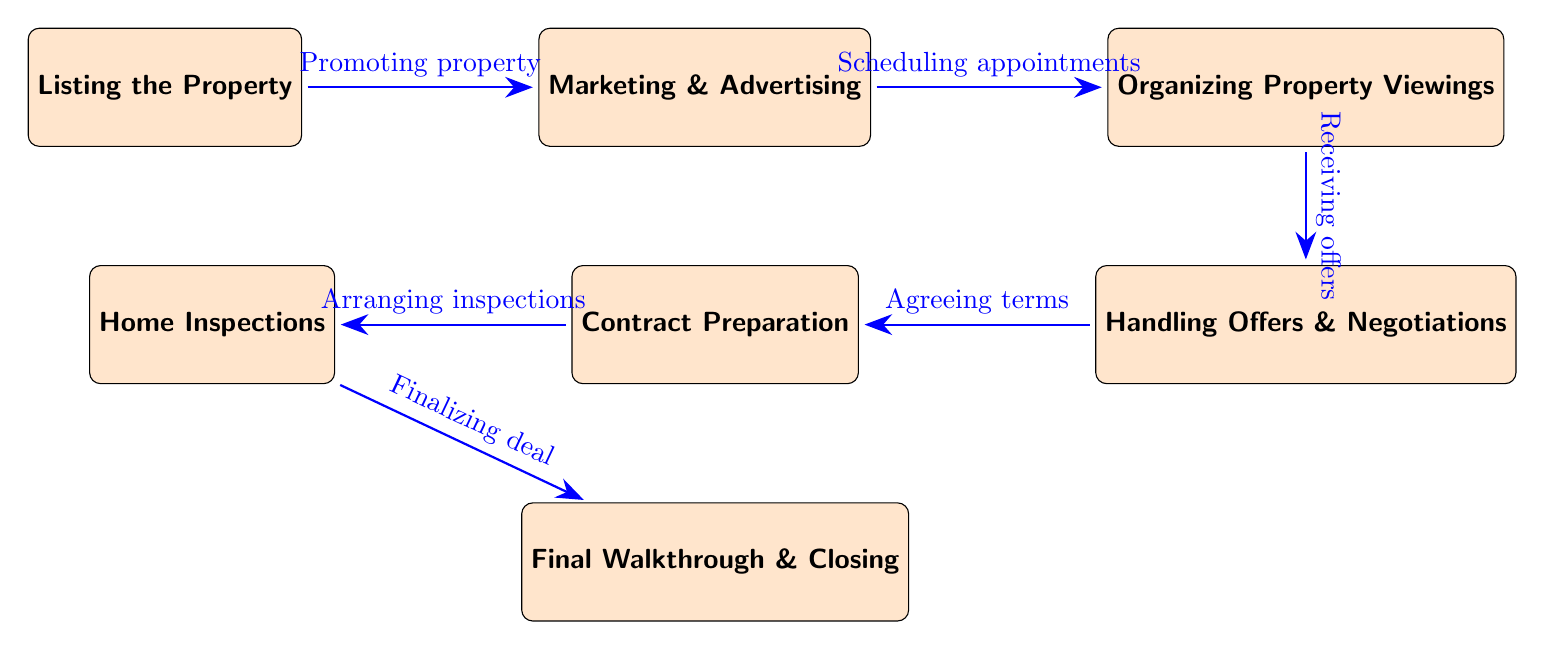What is the first step in the food chain? The first step is represented by the leftmost node, which is "Listing the Property."
Answer: Listing the Property How many nodes are displayed in the diagram? The diagram displays six distinct nodes, each representing a different step in the process.
Answer: 6 What action takes place between marketing and organizing property viewings? The diagram indicates that the action taking place is "Scheduling appointments," which connects these two nodes.
Answer: Scheduling appointments Which step follows "Handling Offers & Negotiations"? The step that follows "Handling Offers & Negotiations" is "Contract Preparation," as seen in the diagram.
Answer: Contract Preparation What are the final two steps in the process? The last two steps indicated in the diagram are "Final Walkthrough" and "Closing."
Answer: Final Walkthrough & Closing What is the connection between "Home Inspections" and "Final Walkthrough & Closing"? The connection is labeled "Finalizing deal," showing that after inspections, the finalization leads to closing.
Answer: Finalizing deal How many actions are documented in the diagram? The diagram illustrates five distinct actions connecting the steps, each represented by arrows.
Answer: 5 Which node is situated directly below "Organizing Property Viewings"? The node located directly below "Organizing Property Viewings" is "Handling Offers & Negotiations."
Answer: Handling Offers & Negotiations What is the last action related to "Contract Preparation"? The last action related to "Contract Preparation" is "Arranging inspections," as it leads to the following node.
Answer: Arranging inspections 